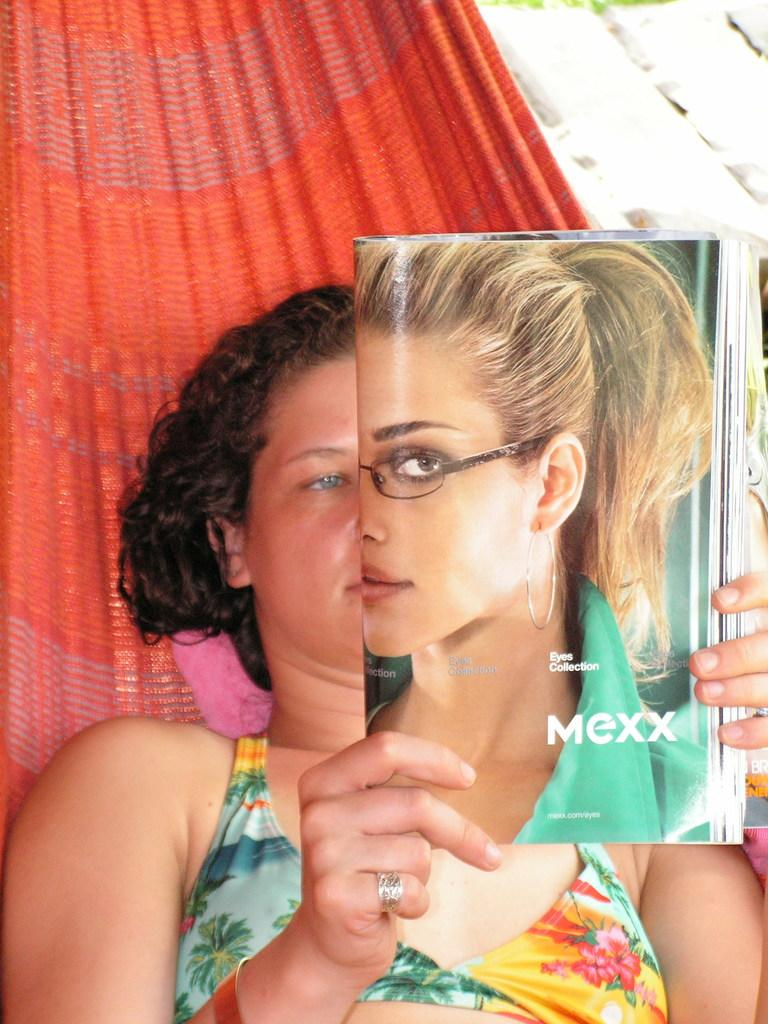Who is present in the image? There is a woman in the image. What is the woman holding in the image? The woman is holding a magazine. What can be seen in the background of the image? There is a red color curtain in the background of the image. What type of calendar is hanging on the wall in the image? There is no calendar present in the image; it only features a woman holding a magazine and a red curtain in the background. 